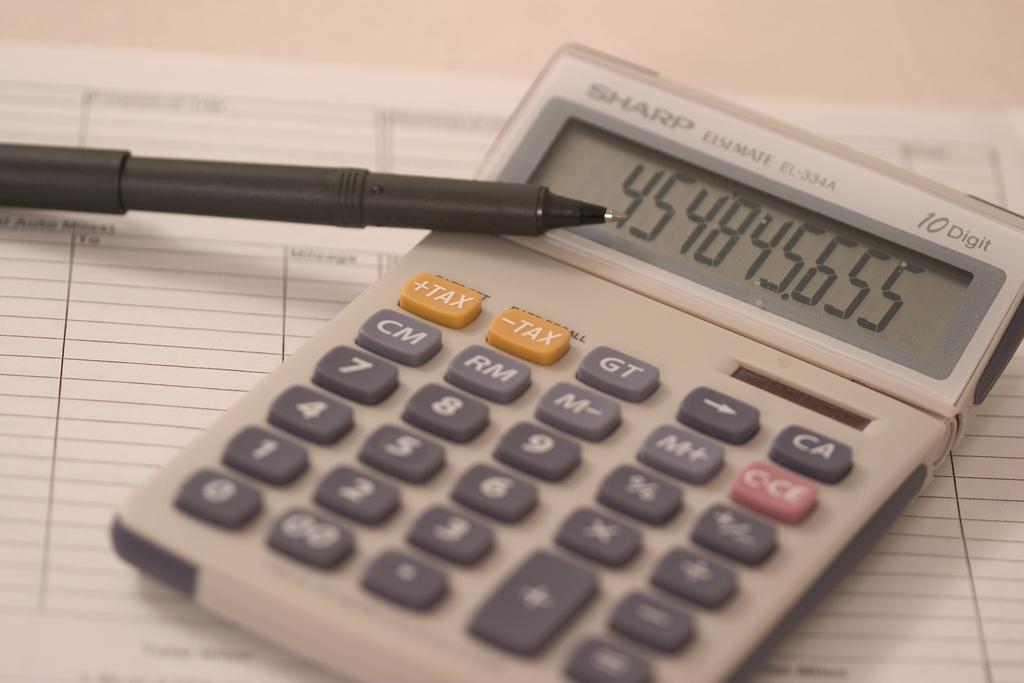What is the brand of this calculator?
Give a very brief answer. Sharp. 